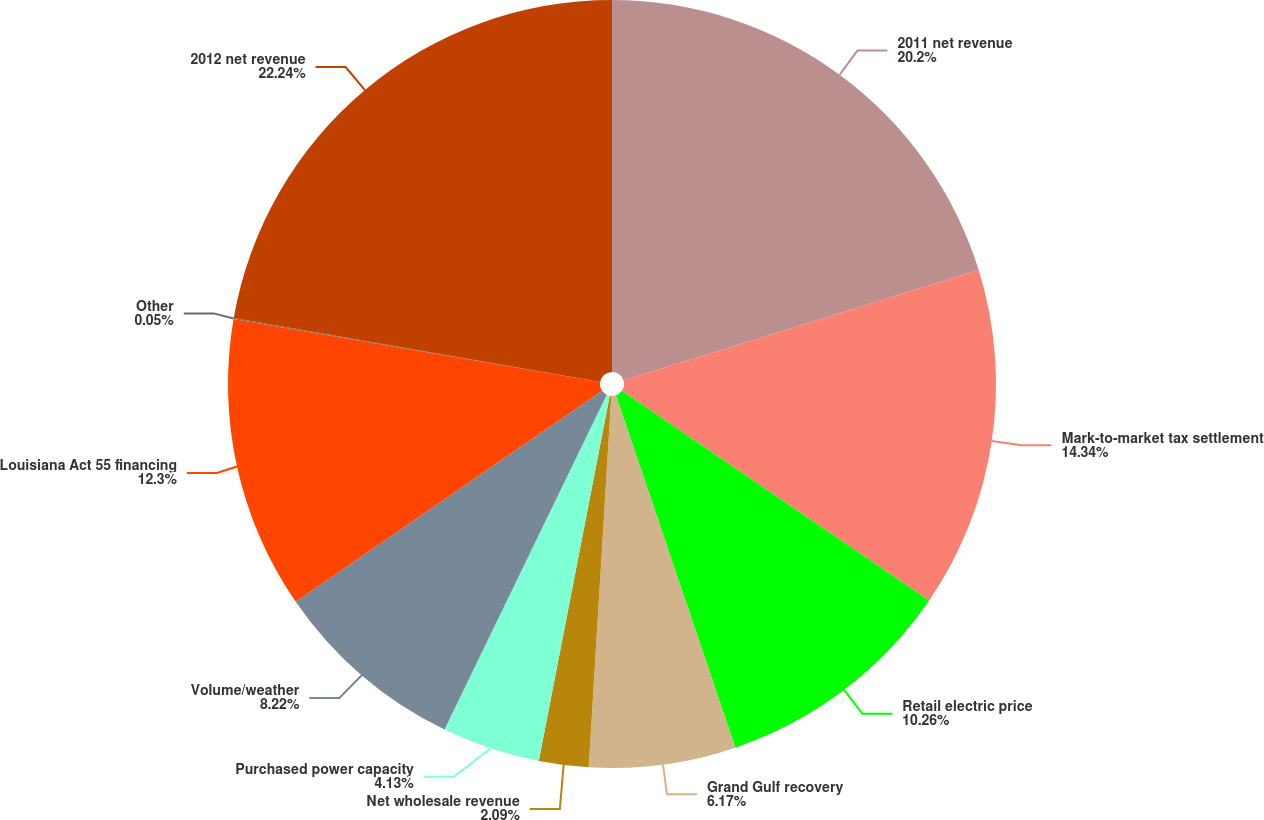<chart> <loc_0><loc_0><loc_500><loc_500><pie_chart><fcel>2011 net revenue<fcel>Mark-to-market tax settlement<fcel>Retail electric price<fcel>Grand Gulf recovery<fcel>Net wholesale revenue<fcel>Purchased power capacity<fcel>Volume/weather<fcel>Louisiana Act 55 financing<fcel>Other<fcel>2012 net revenue<nl><fcel>20.2%<fcel>14.34%<fcel>10.26%<fcel>6.17%<fcel>2.09%<fcel>4.13%<fcel>8.22%<fcel>12.3%<fcel>0.05%<fcel>22.25%<nl></chart> 